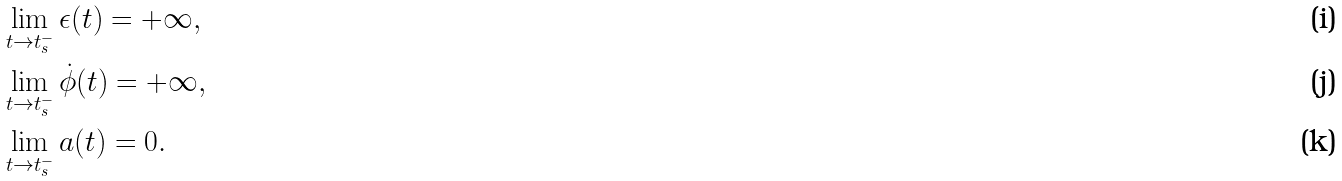Convert formula to latex. <formula><loc_0><loc_0><loc_500><loc_500>& \lim _ { t \to t _ { s } ^ { - } } \epsilon ( t ) = + \infty , \\ & \lim _ { t \to t _ { s } ^ { - } } \dot { \phi } ( t ) = + \infty , \\ & \lim _ { t \to t _ { s } ^ { - } } a ( t ) = 0 .</formula> 